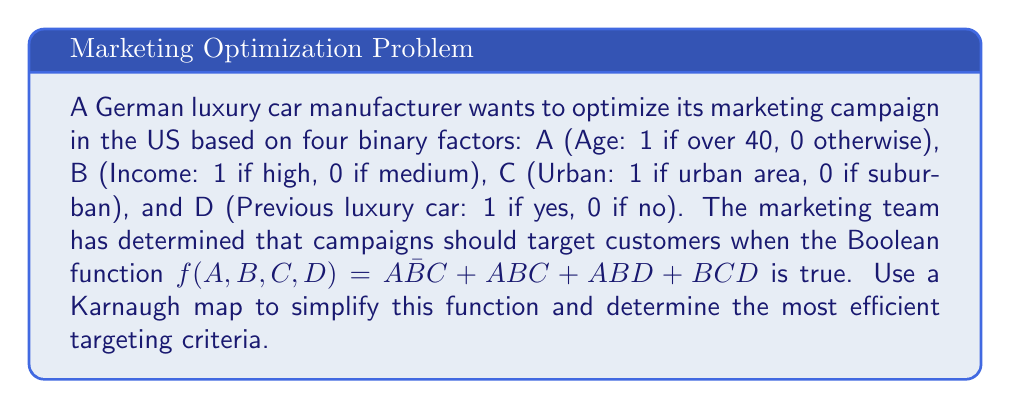Can you solve this math problem? 1. First, we construct a 4-variable Karnaugh map:

[asy]
unitsize(1cm);
draw((0,0)--(4,0)--(4,4)--(0,4)--cycle);
draw((0,1)--(4,1));
draw((0,2)--(4,2));
draw((0,3)--(4,3));
draw((1,0)--(1,4));
draw((2,0)--(2,4));
draw((3,0)--(3,4));
label("00", (0.5,4.5));
label("01", (1.5,4.5));
label("11", (2.5,4.5));
label("10", (3.5,4.5));
label("00", (-0.5,3.5));
label("01", (-0.5,2.5));
label("11", (-0.5,1.5));
label("10", (-0.5,0.5));
label("AB", (-0.5,4.5));
label("CD", (4.5,4.5));
label("1", (0.5,3.5));
label("1", (1.5,1.5));
label("1", (2.5,1.5));
label("1", (2.5,2.5));
label("1", (3.5,1.5));
[/asy]

2. We fill in the Karnaugh map based on the given function:
   $f(A,B,C,D) = A\bar{B}C + ABC + ABD + BCD$

3. Now we look for the largest possible groupings of 1's:
   - There's a group of two 1's in the bottom row: $ABC$
   - There's a group of two 1's in the third column: $ABD$
   - There's a group of two 1's in the right half: $BCD$
   - The remaining 1 can be grouped with the top group: $A\bar{B}C$

4. We can write the simplified function as the sum of these groups:
   $f(A,B,C,D) = ABC + ABD + BCD + A\bar{B}C$

5. This can be further simplified by factoring out common terms:
   $f(A,B,C,D) = AB(C + D) + BC(D + A) + A\bar{B}C$

6. The final simplified function is:
   $f(A,B,C,D) = AB(C + D) + BC(D + A) + A\bar{B}C$

This simplified function represents the most efficient targeting criteria for the marketing campaign.
Answer: $AB(C + D) + BC(D + A) + A\bar{B}C$ 